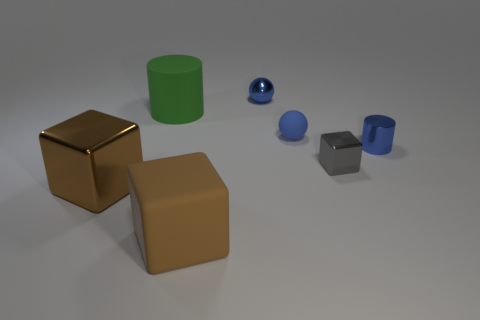Is the color of the block that is right of the big matte cube the same as the large metallic cube?
Your response must be concise. No. There is a rubber sphere; does it have the same color as the object that is in front of the large metallic block?
Give a very brief answer. No. There is a small blue matte sphere; are there any small shiny cylinders left of it?
Make the answer very short. No. Is the material of the large green cylinder the same as the small block?
Offer a terse response. No. There is a cylinder that is the same size as the brown shiny object; what is it made of?
Provide a succinct answer. Rubber. How many things are either things that are to the left of the small cylinder or blue shiny objects?
Offer a terse response. 7. Is the number of small gray metallic blocks to the right of the rubber ball the same as the number of blocks?
Your answer should be very brief. No. Is the large shiny cube the same color as the large matte cylinder?
Your answer should be very brief. No. There is a object that is both behind the small rubber sphere and to the left of the blue metal sphere; what color is it?
Provide a short and direct response. Green. What number of cylinders are either brown objects or green objects?
Make the answer very short. 1. 